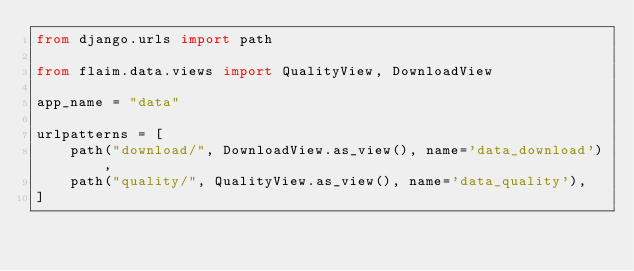Convert code to text. <code><loc_0><loc_0><loc_500><loc_500><_Python_>from django.urls import path

from flaim.data.views import QualityView, DownloadView

app_name = "data"

urlpatterns = [
    path("download/", DownloadView.as_view(), name='data_download'),
    path("quality/", QualityView.as_view(), name='data_quality'),
]
</code> 